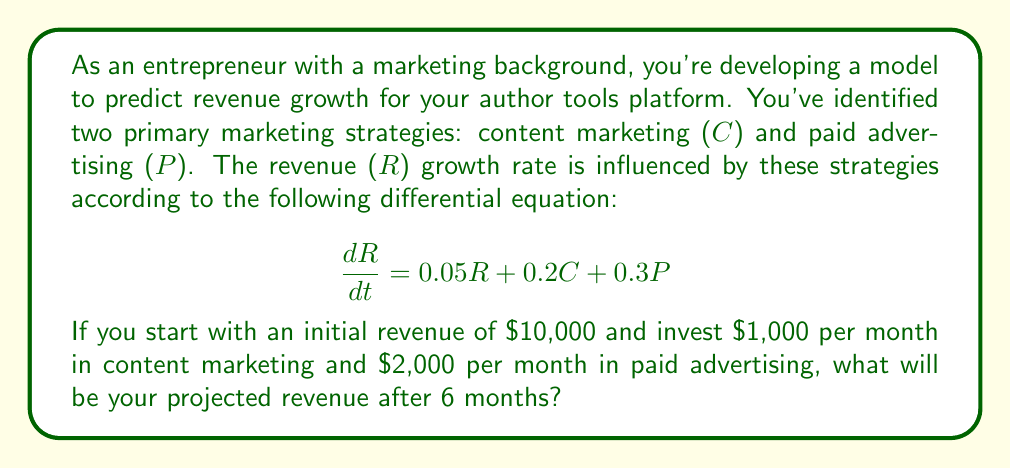Can you solve this math problem? Let's solve this step-by-step:

1) We have the differential equation:
   $$\frac{dR}{dt} = 0.05R + 0.2C + 0.3P$$

2) Given:
   - Initial revenue R(0) = $10,000
   - C = $1,000 per month
   - P = $2,000 per month

3) Substituting the values for C and P:
   $$\frac{dR}{dt} = 0.05R + 0.2(1000) + 0.3(2000) = 0.05R + 200 + 600 = 0.05R + 800$$

4) This is a linear first-order differential equation of the form:
   $$\frac{dR}{dt} = aR + b$$
   where a = 0.05 and b = 800

5) The general solution for this type of equation is:
   $$R(t) = Ce^{at} - \frac{b}{a}$$
   where C is a constant we need to determine

6) Substituting our values:
   $$R(t) = Ce^{0.05t} - \frac{800}{0.05} = Ce^{0.05t} - 16000$$

7) Using the initial condition R(0) = 10,000:
   $$10000 = C - 16000$$
   $$C = 26000$$

8) Our final solution is:
   $$R(t) = 26000e^{0.05t} - 16000$$

9) To find the revenue after 6 months, we substitute t = 6:
   $$R(6) = 26000e^{0.05(6)} - 16000 = 26000e^{0.3} - 16000 \approx 18,509.76$$
Answer: $18,509.76 